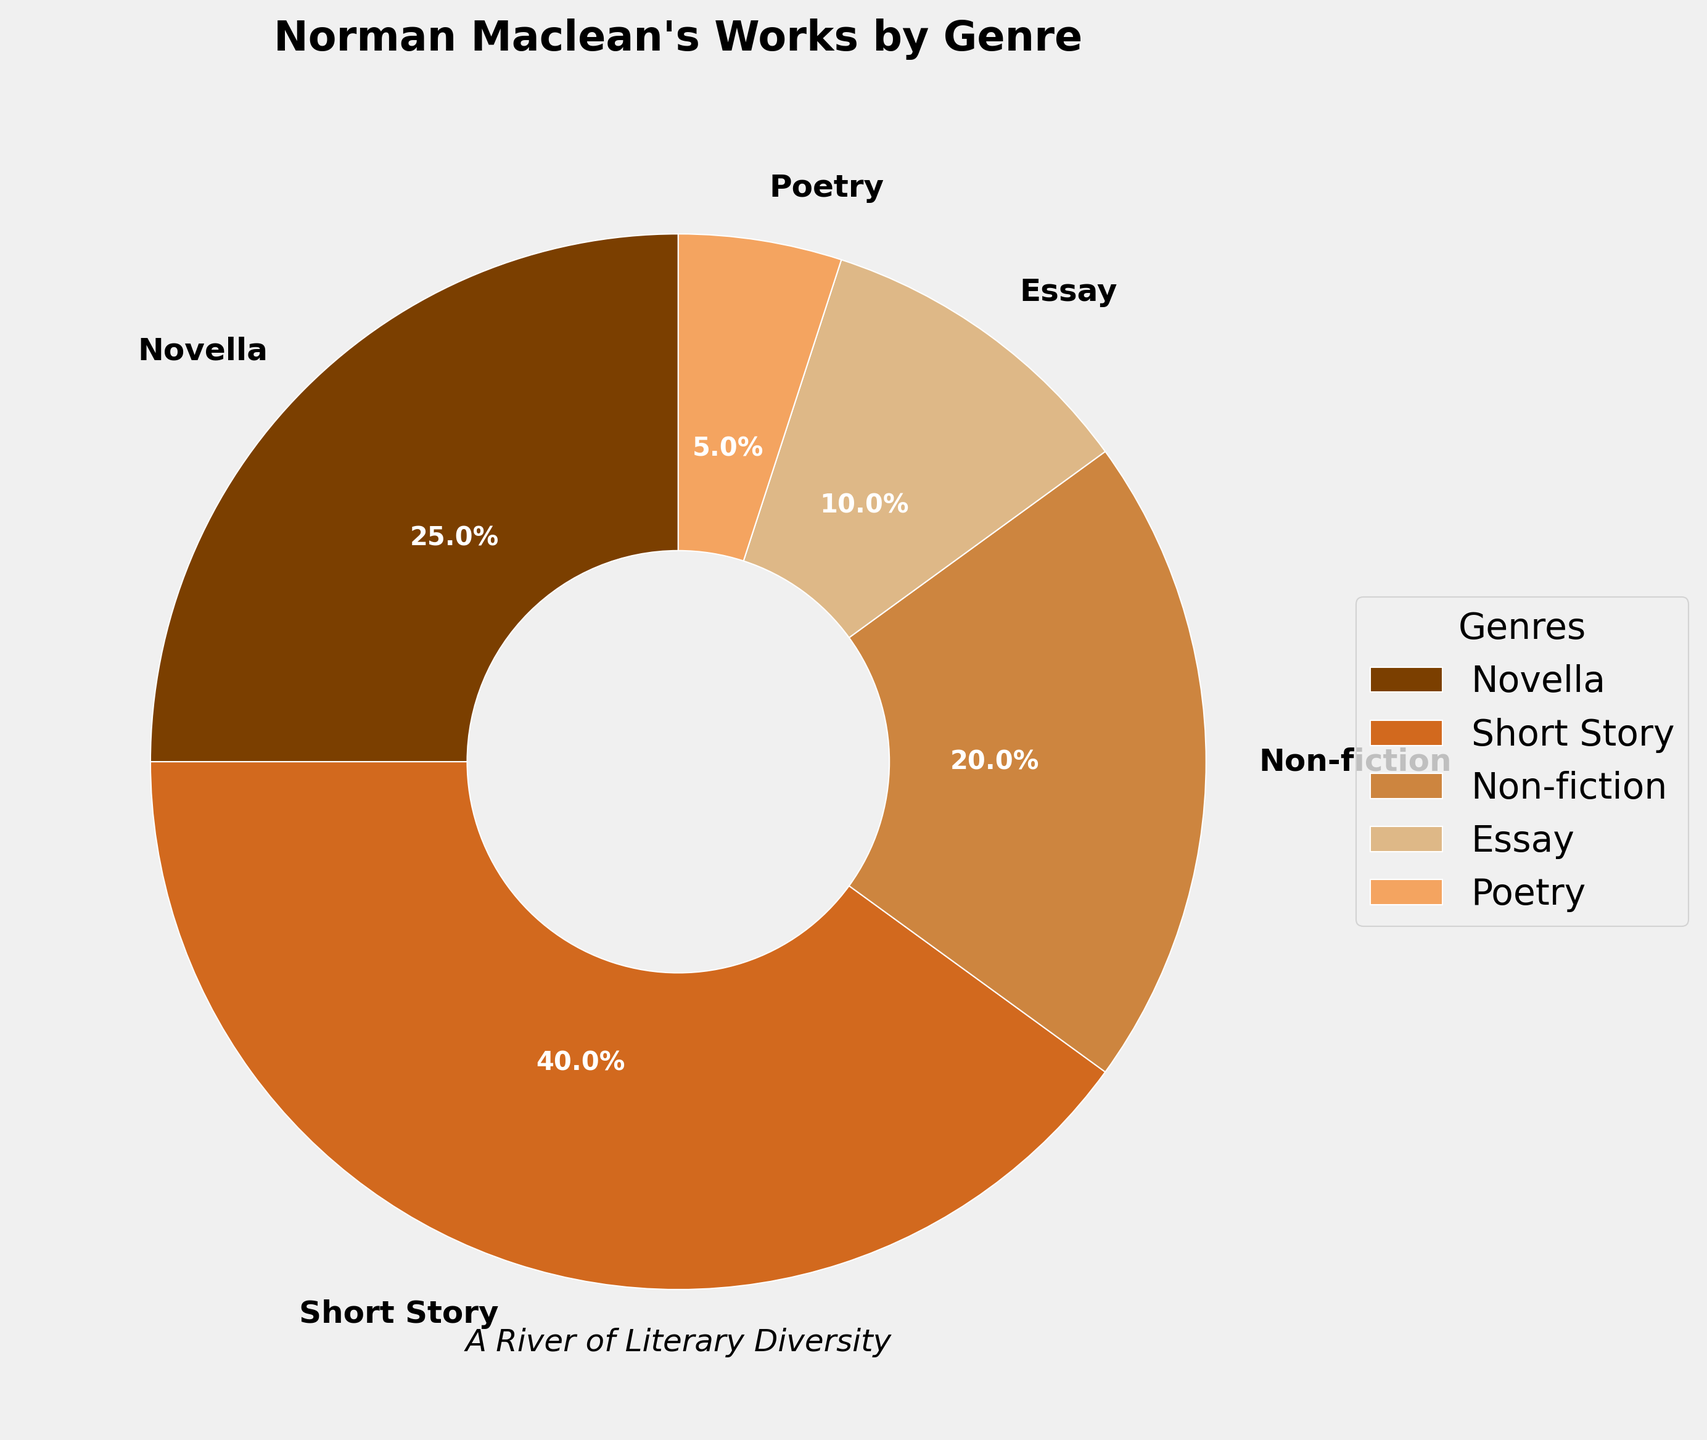Which genre has the highest percentage of Norman Maclean's works? The genre with the highest percentage in the pie chart is the one with the largest wedge represented and percentage label. Here, the "Short Story" section is the largest part of the pie chart with 40%.
Answer: Short Story Which genres together make up more than 50% of Norman Maclean's works? To determine this, we need to sum the percentages of different genres until we exceed 50%. Short Story (40%) + Novella (25%) => 40% + 25% = 65%, which exceeds 50%. These two genres together make up more than 50%.
Answer: Short Story and Novella How much more percentage of Norman Maclean's works are Novellas compared to Essays? The percentage of Novellas is 25%, and Essays are 10%. To find the difference, subtract the percentage of Essays from Novellas: 25% - 10% = 15%.
Answer: 15% Which genre has the smallest percentage of Norman Maclean's works? The smallest percentage in the pie chart will have the smallest wedge and label. Here, Poetry has the smallest part, indicated by 5%.
Answer: Poetry What's the combined percentage of Non-fiction and Essay genres? Sum the percentages of these two genres. Non-fiction is 20% and Essay is 10%, so combined they are 20% + 10% = 30%.
Answer: 30% Are Non-fiction works more or less common than Novellas in Norman Maclean’s publications? Compare the percentages of Non-fiction (20%) and Novella (25%). Since 20% < 25%, Non-fiction works are less common than Novellas.
Answer: Less common Which visual attribute helps identify the different genres in the pie chart? The different genres are identified by their colors and labels assigned to each wedge of the pie chart. The unique color and label for each genre help distinguish them visually.
Answer: Colors and labels If Poetry and Essays were combined into a single genre, what would be their new percentage? To combine Poetry (5%) and Essays (10%), sum their percentages: 5% + 10% = 15%.
Answer: 15% Which genre appears immediately to the right of the "Short Story" section in the pie chart? The pie chart is arranged in a specific order, starting from 90 degrees and moving clockwise. The section immediately to the right of "Short Story" (which starts at the top) is Non-fiction.
Answer: Non-fiction 